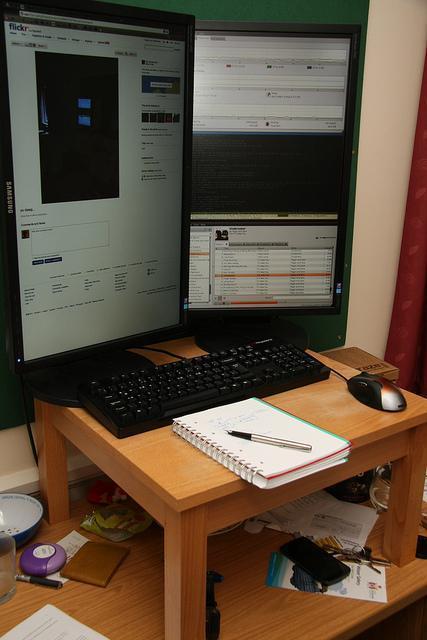How many computer monitors are on the desk?
Give a very brief answer. 3. How many tvs are in the photo?
Give a very brief answer. 2. How many people in the photo?
Give a very brief answer. 0. 